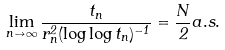Convert formula to latex. <formula><loc_0><loc_0><loc_500><loc_500>\lim _ { n \to \infty } \frac { t _ { n } } { r _ { n } ^ { 2 } ( \log \log t _ { n } ) ^ { - 1 } } = \frac { N } { 2 } a . s .</formula> 